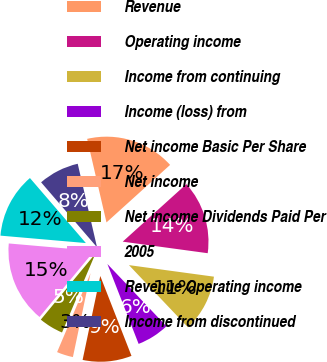Convert chart. <chart><loc_0><loc_0><loc_500><loc_500><pie_chart><fcel>Revenue<fcel>Operating income<fcel>Income from continuing<fcel>Income (loss) from<fcel>Net income Basic Per Share<fcel>Net income<fcel>Net income Dividends Paid Per<fcel>2005<fcel>Revenue Operating income<fcel>Income from discontinued<nl><fcel>16.92%<fcel>13.85%<fcel>10.77%<fcel>6.15%<fcel>9.23%<fcel>3.08%<fcel>4.62%<fcel>15.38%<fcel>12.31%<fcel>7.69%<nl></chart> 